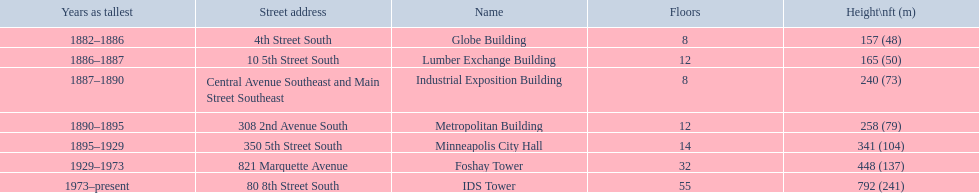What was the first building named as the tallest? Globe Building. 